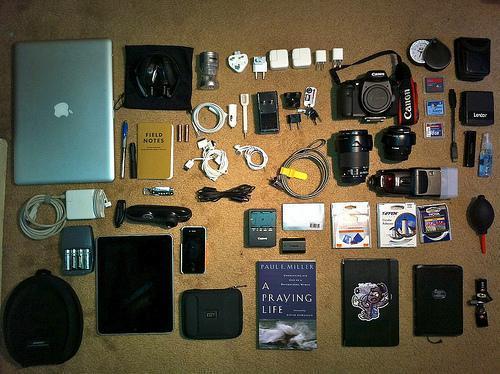How many batteries are shown?
Give a very brief answer. 4. 